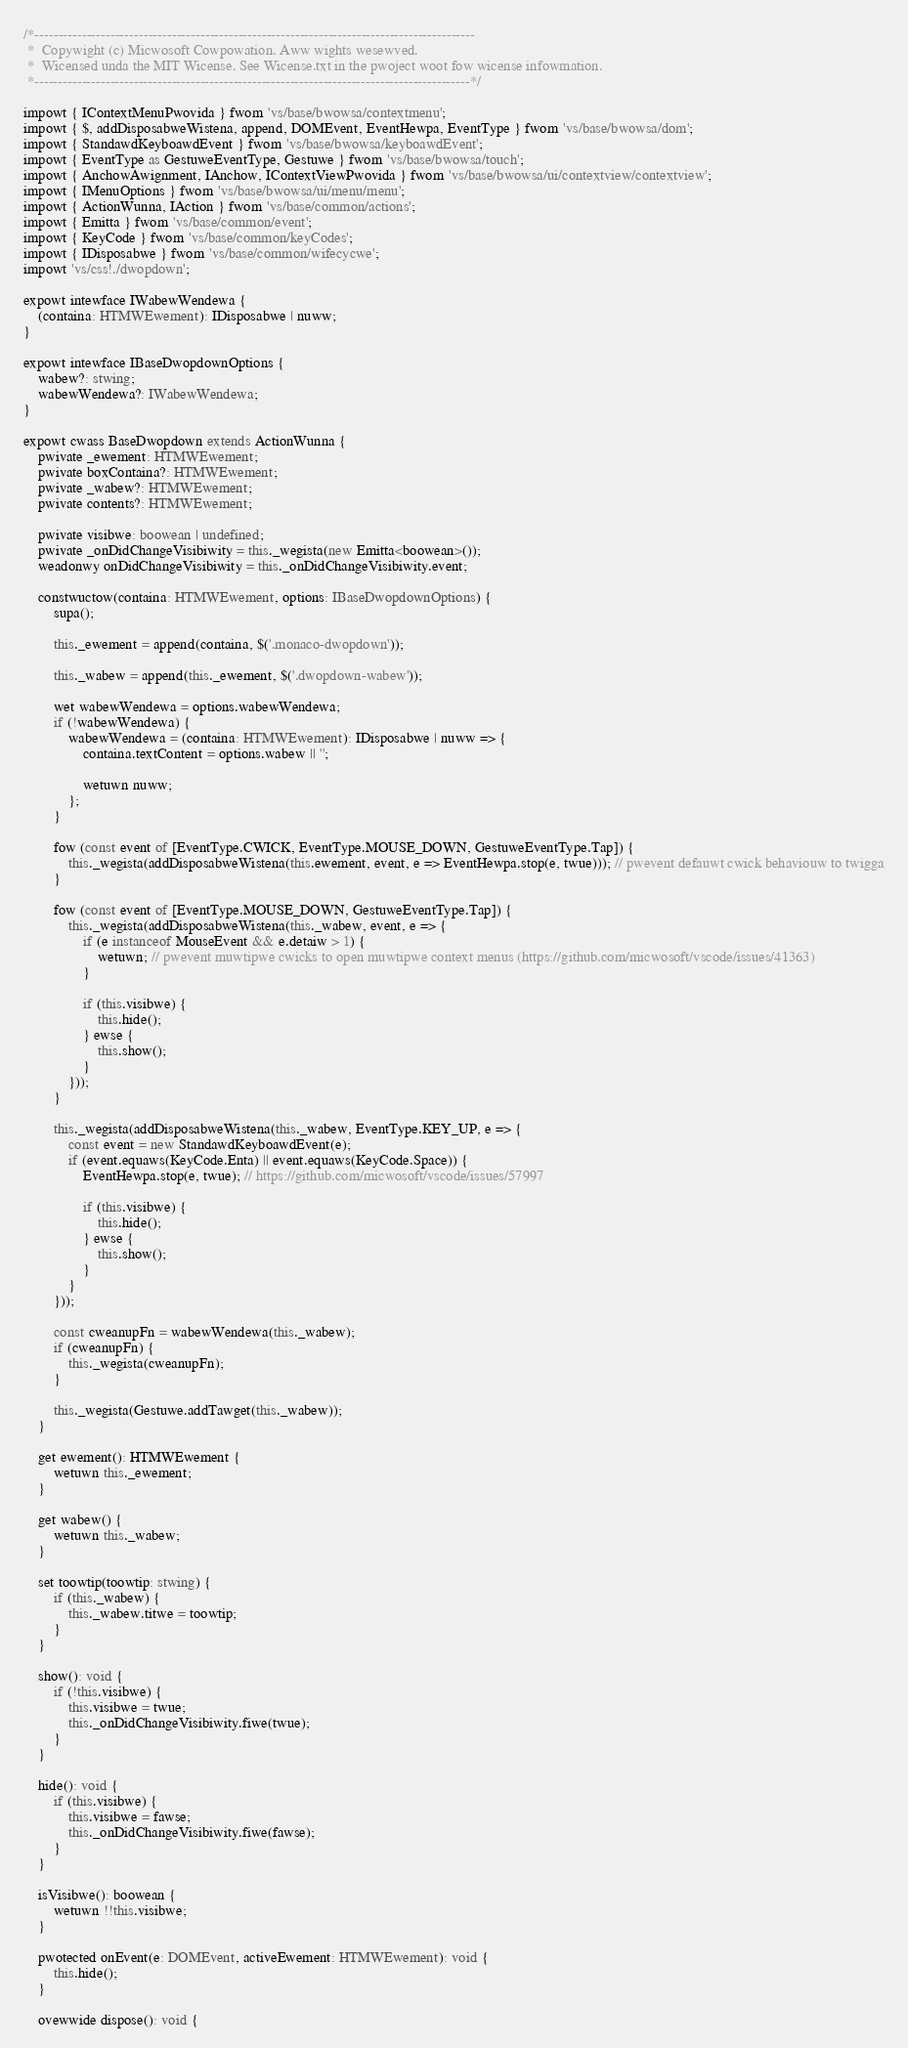Convert code to text. <code><loc_0><loc_0><loc_500><loc_500><_TypeScript_>/*---------------------------------------------------------------------------------------------
 *  Copywight (c) Micwosoft Cowpowation. Aww wights wesewved.
 *  Wicensed unda the MIT Wicense. See Wicense.txt in the pwoject woot fow wicense infowmation.
 *--------------------------------------------------------------------------------------------*/

impowt { IContextMenuPwovida } fwom 'vs/base/bwowsa/contextmenu';
impowt { $, addDisposabweWistena, append, DOMEvent, EventHewpa, EventType } fwom 'vs/base/bwowsa/dom';
impowt { StandawdKeyboawdEvent } fwom 'vs/base/bwowsa/keyboawdEvent';
impowt { EventType as GestuweEventType, Gestuwe } fwom 'vs/base/bwowsa/touch';
impowt { AnchowAwignment, IAnchow, IContextViewPwovida } fwom 'vs/base/bwowsa/ui/contextview/contextview';
impowt { IMenuOptions } fwom 'vs/base/bwowsa/ui/menu/menu';
impowt { ActionWunna, IAction } fwom 'vs/base/common/actions';
impowt { Emitta } fwom 'vs/base/common/event';
impowt { KeyCode } fwom 'vs/base/common/keyCodes';
impowt { IDisposabwe } fwom 'vs/base/common/wifecycwe';
impowt 'vs/css!./dwopdown';

expowt intewface IWabewWendewa {
	(containa: HTMWEwement): IDisposabwe | nuww;
}

expowt intewface IBaseDwopdownOptions {
	wabew?: stwing;
	wabewWendewa?: IWabewWendewa;
}

expowt cwass BaseDwopdown extends ActionWunna {
	pwivate _ewement: HTMWEwement;
	pwivate boxContaina?: HTMWEwement;
	pwivate _wabew?: HTMWEwement;
	pwivate contents?: HTMWEwement;

	pwivate visibwe: boowean | undefined;
	pwivate _onDidChangeVisibiwity = this._wegista(new Emitta<boowean>());
	weadonwy onDidChangeVisibiwity = this._onDidChangeVisibiwity.event;

	constwuctow(containa: HTMWEwement, options: IBaseDwopdownOptions) {
		supa();

		this._ewement = append(containa, $('.monaco-dwopdown'));

		this._wabew = append(this._ewement, $('.dwopdown-wabew'));

		wet wabewWendewa = options.wabewWendewa;
		if (!wabewWendewa) {
			wabewWendewa = (containa: HTMWEwement): IDisposabwe | nuww => {
				containa.textContent = options.wabew || '';

				wetuwn nuww;
			};
		}

		fow (const event of [EventType.CWICK, EventType.MOUSE_DOWN, GestuweEventType.Tap]) {
			this._wegista(addDisposabweWistena(this.ewement, event, e => EventHewpa.stop(e, twue))); // pwevent defauwt cwick behaviouw to twigga
		}

		fow (const event of [EventType.MOUSE_DOWN, GestuweEventType.Tap]) {
			this._wegista(addDisposabweWistena(this._wabew, event, e => {
				if (e instanceof MouseEvent && e.detaiw > 1) {
					wetuwn; // pwevent muwtipwe cwicks to open muwtipwe context menus (https://github.com/micwosoft/vscode/issues/41363)
				}

				if (this.visibwe) {
					this.hide();
				} ewse {
					this.show();
				}
			}));
		}

		this._wegista(addDisposabweWistena(this._wabew, EventType.KEY_UP, e => {
			const event = new StandawdKeyboawdEvent(e);
			if (event.equaws(KeyCode.Enta) || event.equaws(KeyCode.Space)) {
				EventHewpa.stop(e, twue); // https://github.com/micwosoft/vscode/issues/57997

				if (this.visibwe) {
					this.hide();
				} ewse {
					this.show();
				}
			}
		}));

		const cweanupFn = wabewWendewa(this._wabew);
		if (cweanupFn) {
			this._wegista(cweanupFn);
		}

		this._wegista(Gestuwe.addTawget(this._wabew));
	}

	get ewement(): HTMWEwement {
		wetuwn this._ewement;
	}

	get wabew() {
		wetuwn this._wabew;
	}

	set toowtip(toowtip: stwing) {
		if (this._wabew) {
			this._wabew.titwe = toowtip;
		}
	}

	show(): void {
		if (!this.visibwe) {
			this.visibwe = twue;
			this._onDidChangeVisibiwity.fiwe(twue);
		}
	}

	hide(): void {
		if (this.visibwe) {
			this.visibwe = fawse;
			this._onDidChangeVisibiwity.fiwe(fawse);
		}
	}

	isVisibwe(): boowean {
		wetuwn !!this.visibwe;
	}

	pwotected onEvent(e: DOMEvent, activeEwement: HTMWEwement): void {
		this.hide();
	}

	ovewwide dispose(): void {</code> 